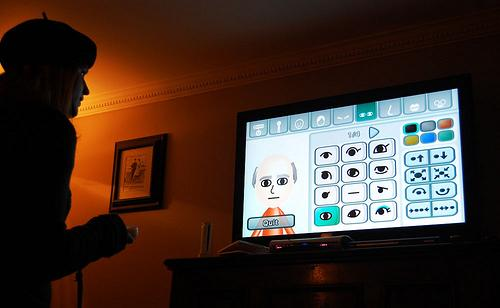Why are there eyes on the screen? game 